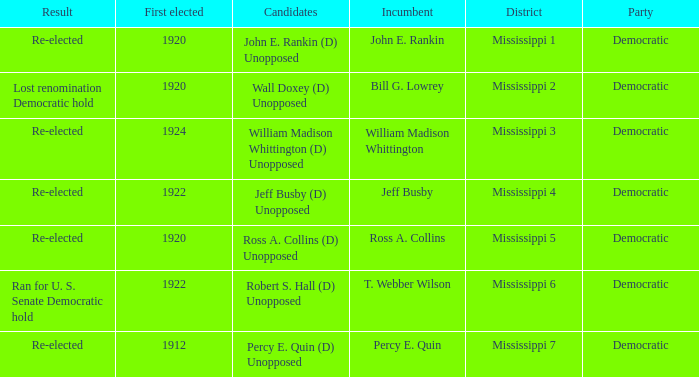What was the result of the election featuring william madison whittington? Re-elected. 